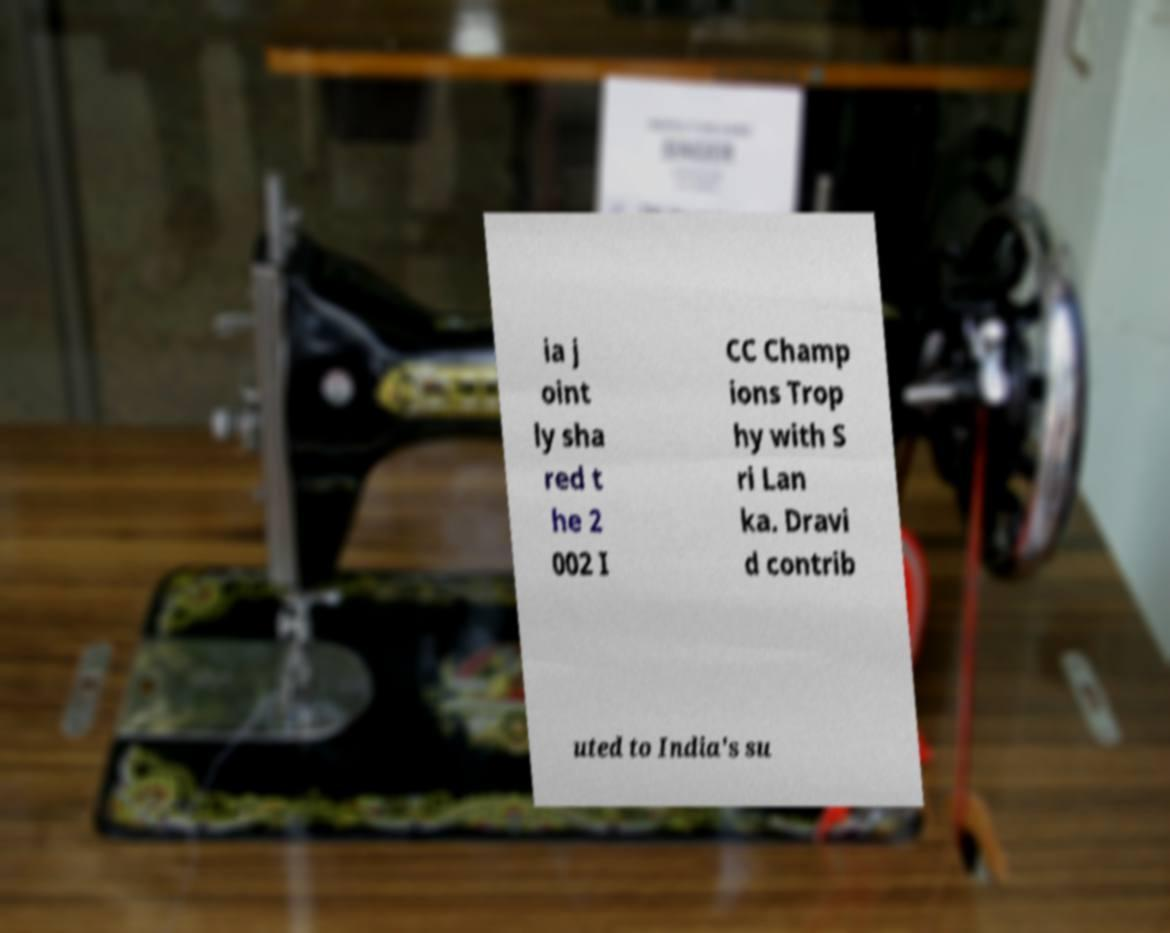Please identify and transcribe the text found in this image. ia j oint ly sha red t he 2 002 I CC Champ ions Trop hy with S ri Lan ka. Dravi d contrib uted to India's su 